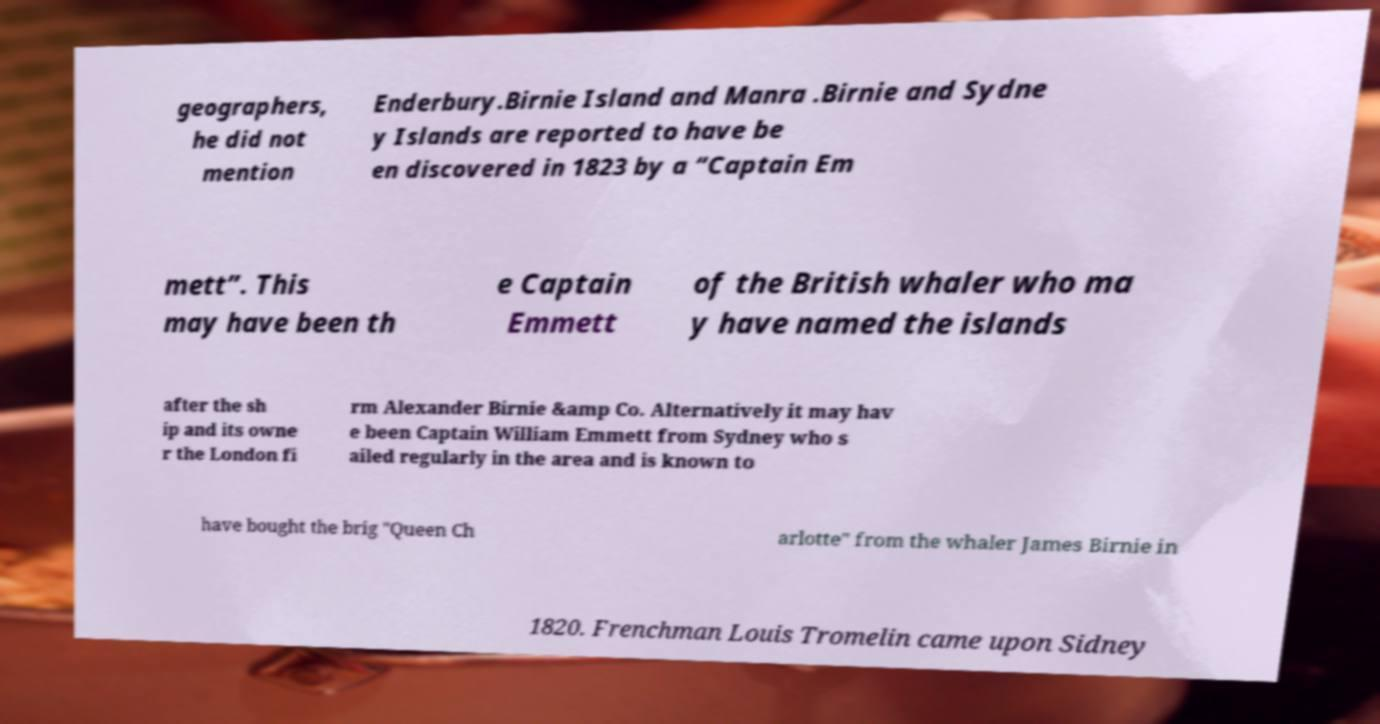Can you read and provide the text displayed in the image?This photo seems to have some interesting text. Can you extract and type it out for me? geographers, he did not mention Enderbury.Birnie Island and Manra .Birnie and Sydne y Islands are reported to have be en discovered in 1823 by a “Captain Em mett”. This may have been th e Captain Emmett of the British whaler who ma y have named the islands after the sh ip and its owne r the London fi rm Alexander Birnie &amp Co. Alternatively it may hav e been Captain William Emmett from Sydney who s ailed regularly in the area and is known to have bought the brig "Queen Ch arlotte" from the whaler James Birnie in 1820. Frenchman Louis Tromelin came upon Sidney 